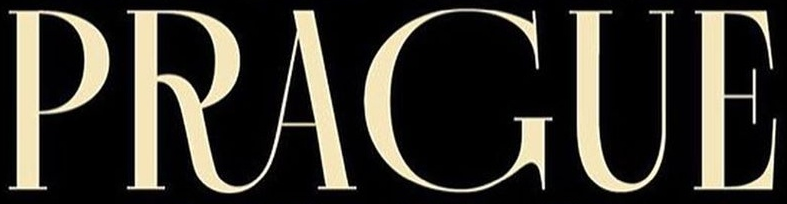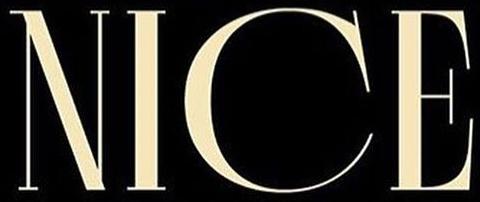What text is displayed in these images sequentially, separated by a semicolon? PRAGUE; NICE 